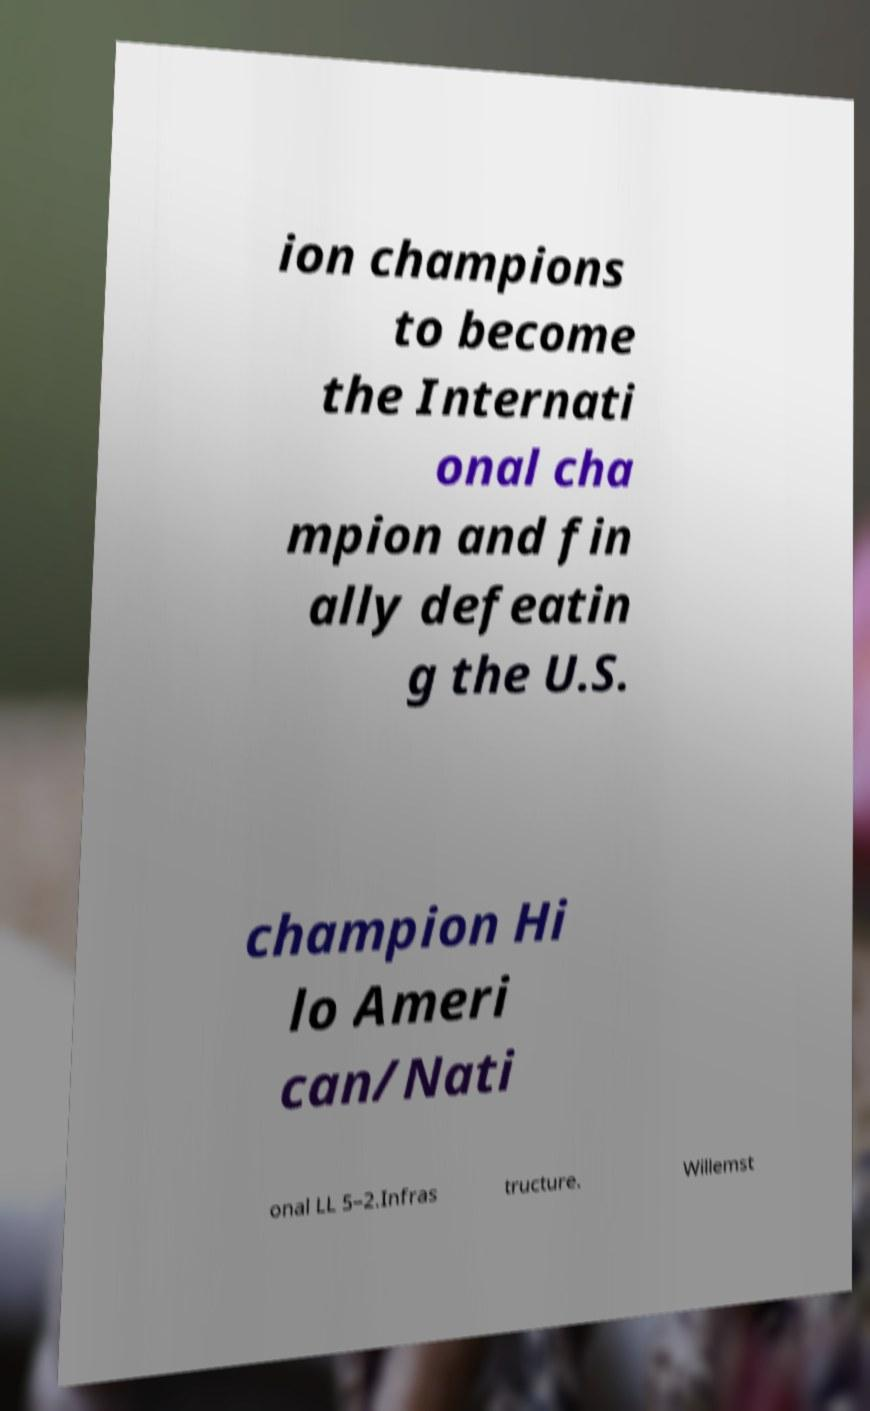For documentation purposes, I need the text within this image transcribed. Could you provide that? ion champions to become the Internati onal cha mpion and fin ally defeatin g the U.S. champion Hi lo Ameri can/Nati onal LL 5–2.Infras tructure. Willemst 